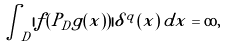<formula> <loc_0><loc_0><loc_500><loc_500>\int _ { D } | f ( P _ { D } g ( x ) ) | \delta ^ { q } ( x ) \, d x = \infty ,</formula> 